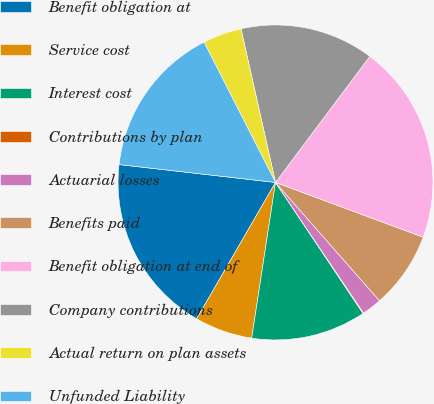Convert chart. <chart><loc_0><loc_0><loc_500><loc_500><pie_chart><fcel>Benefit obligation at<fcel>Service cost<fcel>Interest cost<fcel>Contributions by plan<fcel>Actuarial losses<fcel>Benefits paid<fcel>Benefit obligation at end of<fcel>Company contributions<fcel>Actual return on plan assets<fcel>Unfunded Liability<nl><fcel>18.47%<fcel>5.93%<fcel>11.79%<fcel>0.07%<fcel>2.03%<fcel>7.88%<fcel>20.43%<fcel>13.74%<fcel>3.98%<fcel>15.69%<nl></chart> 